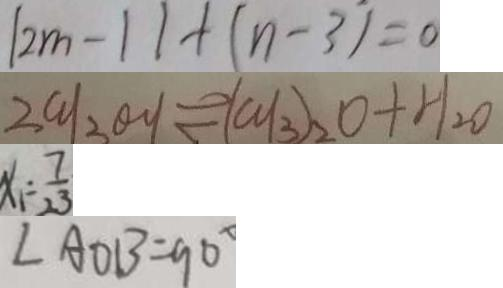<formula> <loc_0><loc_0><loc_500><loc_500>[ 2 m - 1 ] + ( n - 3 ) = 0 
 2 c y _ { 3 } \theta y \rightleftharpoons ( c y _ { 3 } ) _ { 2 } O + H _ { 2 } O 
 x _ { 1 } = \frac { 7 } { 2 3 } 
 \angle A O B = 9 0 ^ { \circ }</formula> 